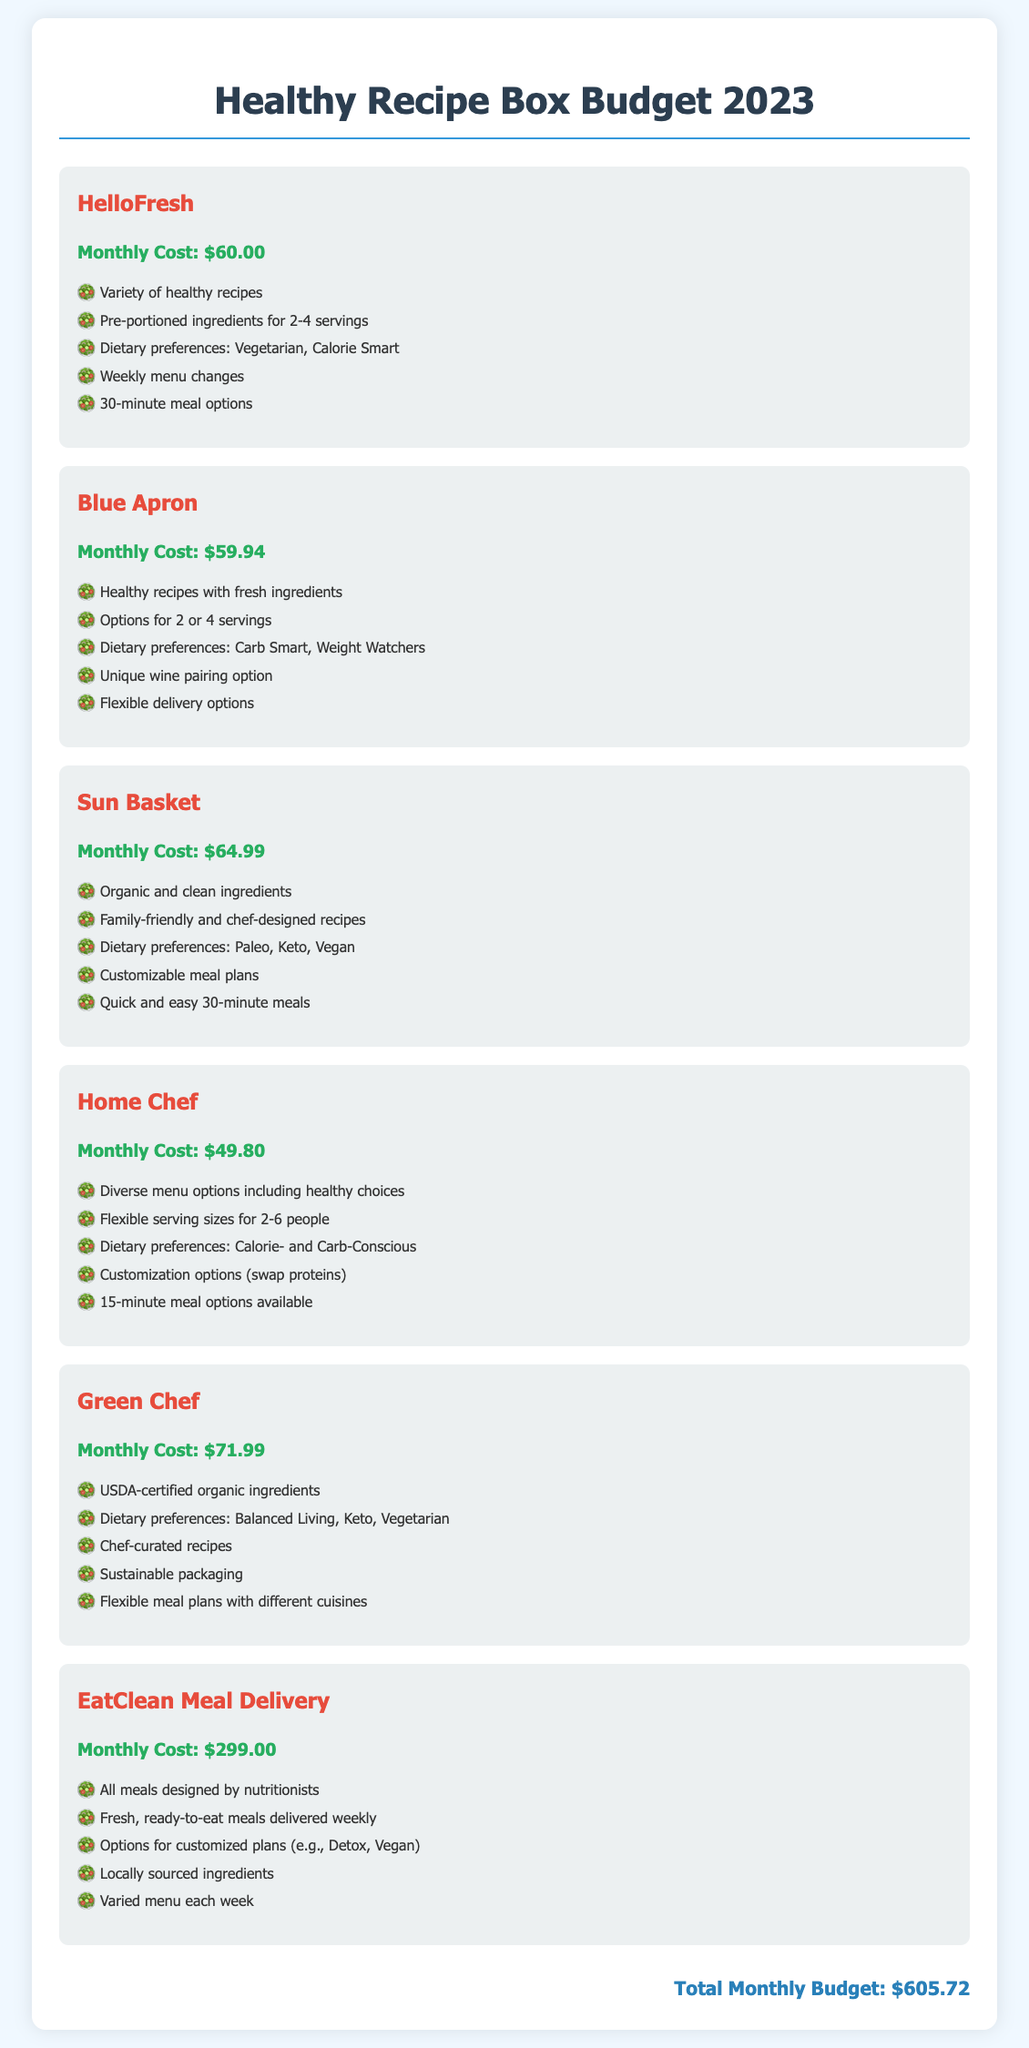What is the monthly cost of HelloFresh? The monthly cost of HelloFresh is explicitly stated in the document.
Answer: $60.00 How many servings does Blue Apron offer options for? The document specifies the serving options available for Blue Apron.
Answer: 2 or 4 servings Which service has the highest monthly cost? To determine the service with the highest monthly cost, we can compare all listed monthly costs for each service.
Answer: EatClean Meal Delivery What dietary preferences does Sun Basket offer? The document lists the specific dietary preferences that Sun Basket supports.
Answer: Paleo, Keto, Vegan What is the total monthly budget for the services listed? The total monthly budget is the sum of the individual service costs shown in the document.
Answer: $605.72 Which service offers customization options? The document highlights which services provide flexibility in meal customization options.
Answer: Home Chef How many features does Green Chef have listed? The document outlines the specific features associated with Green Chef.
Answer: 5 features What is one of the meal options that Home Chef provides? The document notes specific meal options available under Home Chef.
Answer: 15-minute meal options available What type of ingredients does Green Chef use? The use of certain types of ingredients is mentioned in relation to Green Chef in the document.
Answer: USDA-certified organic ingredients 